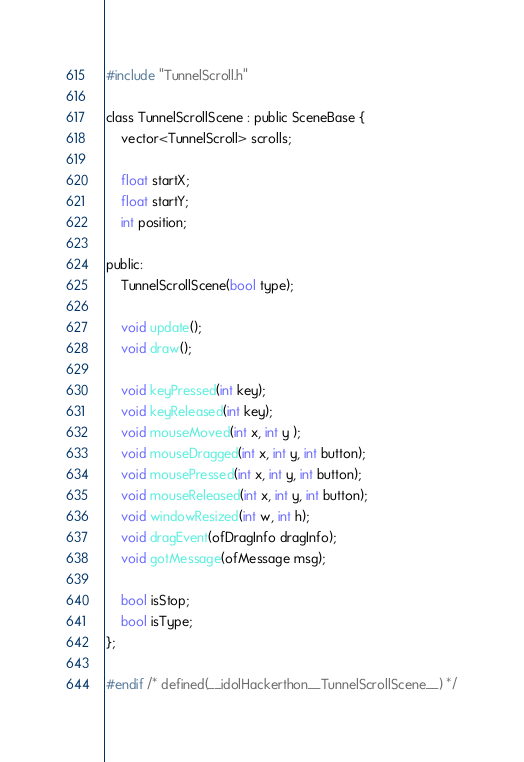<code> <loc_0><loc_0><loc_500><loc_500><_C_>#include "TunnelScroll.h"

class TunnelScrollScene : public SceneBase {
    vector<TunnelScroll> scrolls;
    
    float startX;
    float startY;
    int position;
    
public:
    TunnelScrollScene(bool type);
    
    void update();
    void draw();
    
    void keyPressed(int key);
    void keyReleased(int key);
    void mouseMoved(int x, int y );
    void mouseDragged(int x, int y, int button);
    void mousePressed(int x, int y, int button);
    void mouseReleased(int x, int y, int button);
    void windowResized(int w, int h);
    void dragEvent(ofDragInfo dragInfo);
    void gotMessage(ofMessage msg);
    
    bool isStop;
    bool isType;
};

#endif /* defined(__idolHackerthon__TunnelScrollScene__) */
</code> 